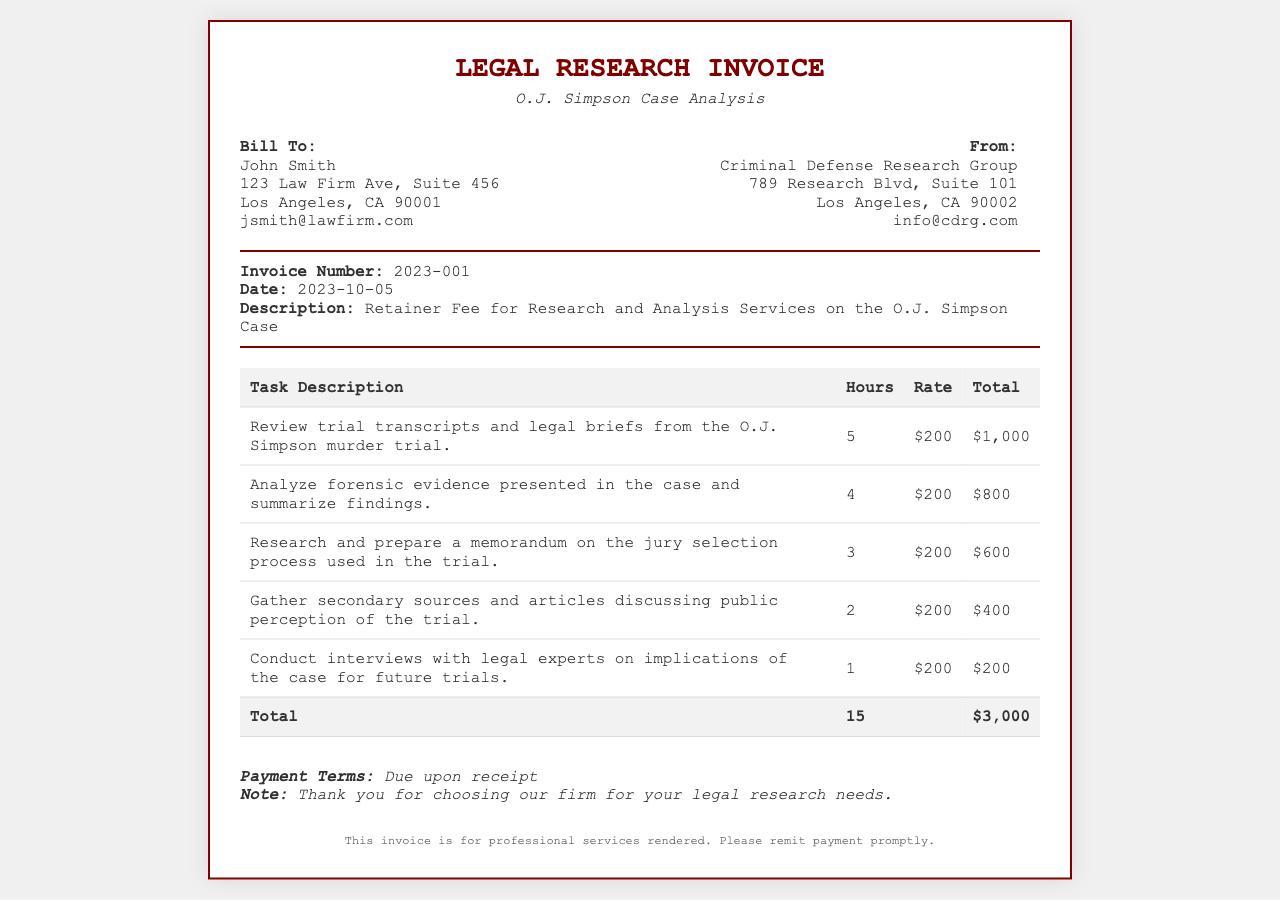What is the invoice number? The invoice number is clearly stated in the details section of the document.
Answer: 2023-001 Who is the client? The client is identified in the "Bill To" section of the invoice.
Answer: John Smith What is the total amount due? The total amount due is provided at the bottom of the invoice.
Answer: $3,000 How many hours were worked in total? The total hours worked can be calculated by summing the hours listed in the tasks.
Answer: 15 What is the rate per hour for the services? The hourly rate is mentioned in each task description.
Answer: $200 What date was the invoice issued? The date of the invoice is explicitly mentioned in the details section.
Answer: 2023-10-05 What is one of the tasks performed? The tasks performed are listed in the table of the invoice.
Answer: Review trial transcripts and legal briefs from the O.J. Simpson murder trial What is the payment term? Payment terms are specified at the bottom of the invoice.
Answer: Due upon receipt What firm issued the invoice? The firm that issued the invoice is indicated in the "From" section.
Answer: Criminal Defense Research Group 